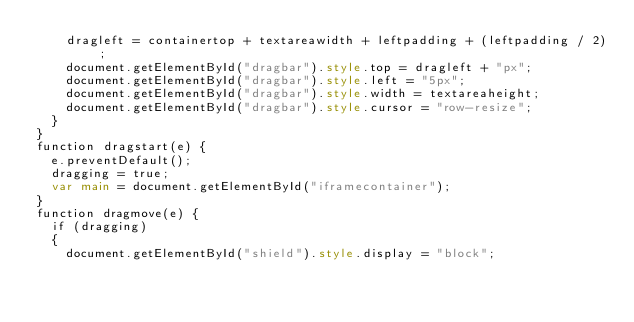Convert code to text. <code><loc_0><loc_0><loc_500><loc_500><_HTML_>    dragleft = containertop + textareawidth + leftpadding + (leftpadding / 2);
    document.getElementById("dragbar").style.top = dragleft + "px";
    document.getElementById("dragbar").style.left = "5px";
    document.getElementById("dragbar").style.width = textareaheight;
    document.getElementById("dragbar").style.cursor = "row-resize";        
  }
}
function dragstart(e) {
  e.preventDefault();
  dragging = true;
  var main = document.getElementById("iframecontainer");
}
function dragmove(e) {
  if (dragging) 
  {
    document.getElementById("shield").style.display = "block";        </code> 